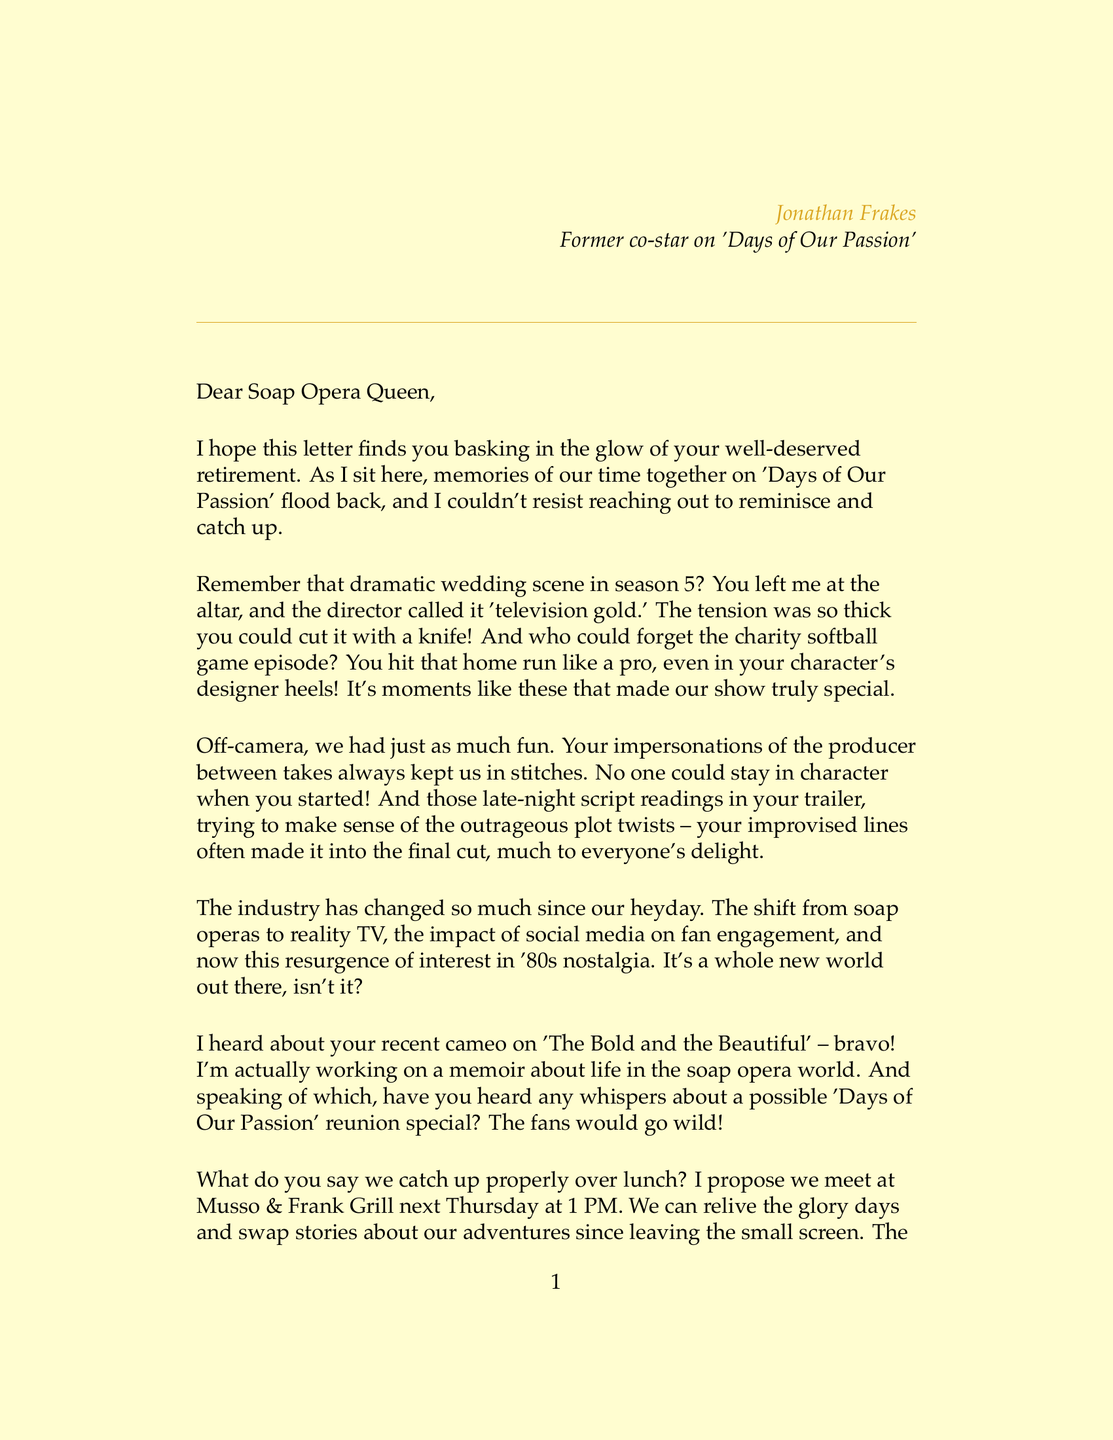What is the sender's name? The sender's name is mentioned at the beginning of the letter as the person writing it.
Answer: Jonathan Frakes What show did they co-star in? The letter references a specific show that both the sender and the recipient starred in together.
Answer: Days of Our Passion What memorable scene is discussed in the letter? The letter recalls a specific scene from the show that had significant impact.
Answer: The dramatic wedding scene in season 5 Where do they propose to meet for lunch? The letter includes a specific location where the sender suggests to meet.
Answer: Musso & Frank Grill What day and time is the proposed lunch meeting? The letter specifies a particular day and time for the catch-up meeting.
Answer: Next Thursday at 1 PM What is one major change in the industry mentioned? The letter lists a change in the industry that has occurred since their time on the show.
Answer: The shift from soap operas to reality TV What was a fun off-camera activity mentioned? The letter recalls a specific enjoyable activity that happened behind the scenes.
Answer: Practical jokes between takes What will Jonathan Frakes be working on? The letter reveals that the sender is undertaking a specific project related to their past experiences.
Answer: A memoir about life in the soap opera world What did the director call the wedding scene? The letter quotes the director's description of the wedding scene, indicating its importance.
Answer: Television gold 